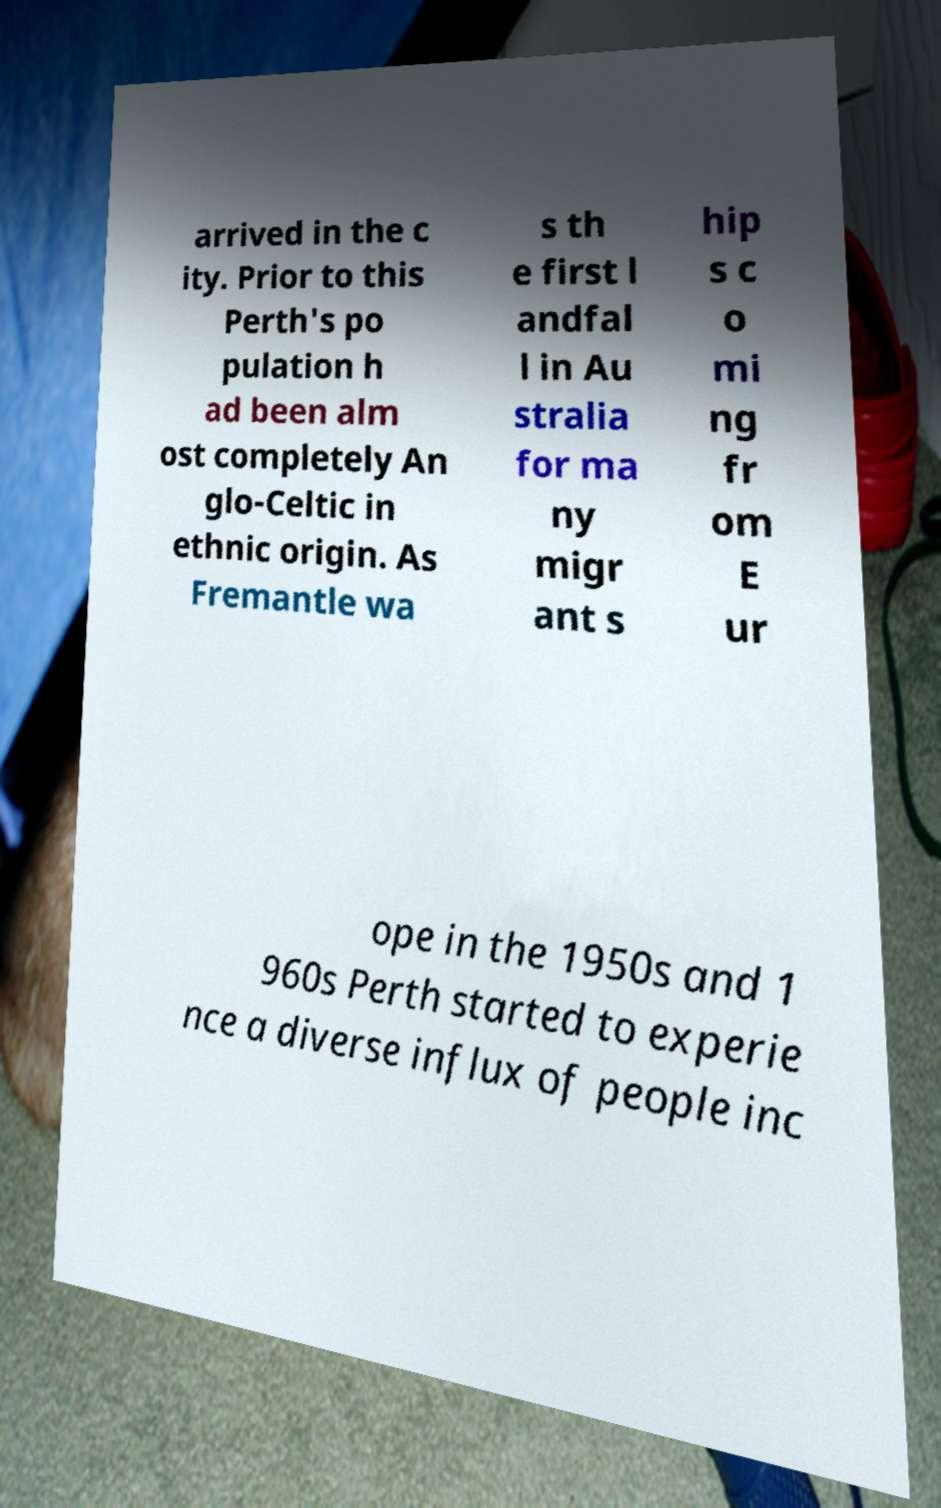I need the written content from this picture converted into text. Can you do that? arrived in the c ity. Prior to this Perth's po pulation h ad been alm ost completely An glo-Celtic in ethnic origin. As Fremantle wa s th e first l andfal l in Au stralia for ma ny migr ant s hip s c o mi ng fr om E ur ope in the 1950s and 1 960s Perth started to experie nce a diverse influx of people inc 